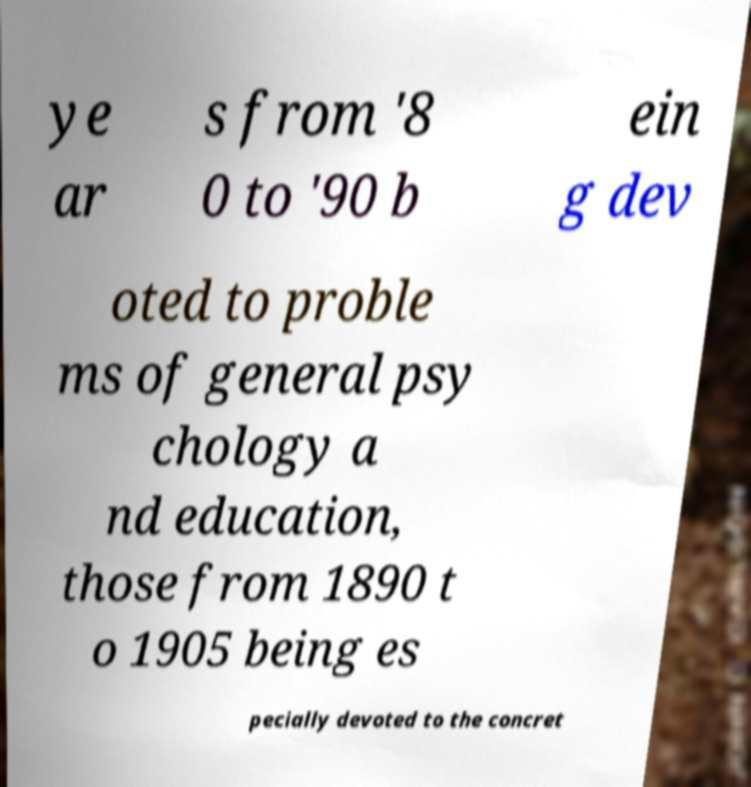Could you assist in decoding the text presented in this image and type it out clearly? ye ar s from '8 0 to '90 b ein g dev oted to proble ms of general psy chology a nd education, those from 1890 t o 1905 being es pecially devoted to the concret 